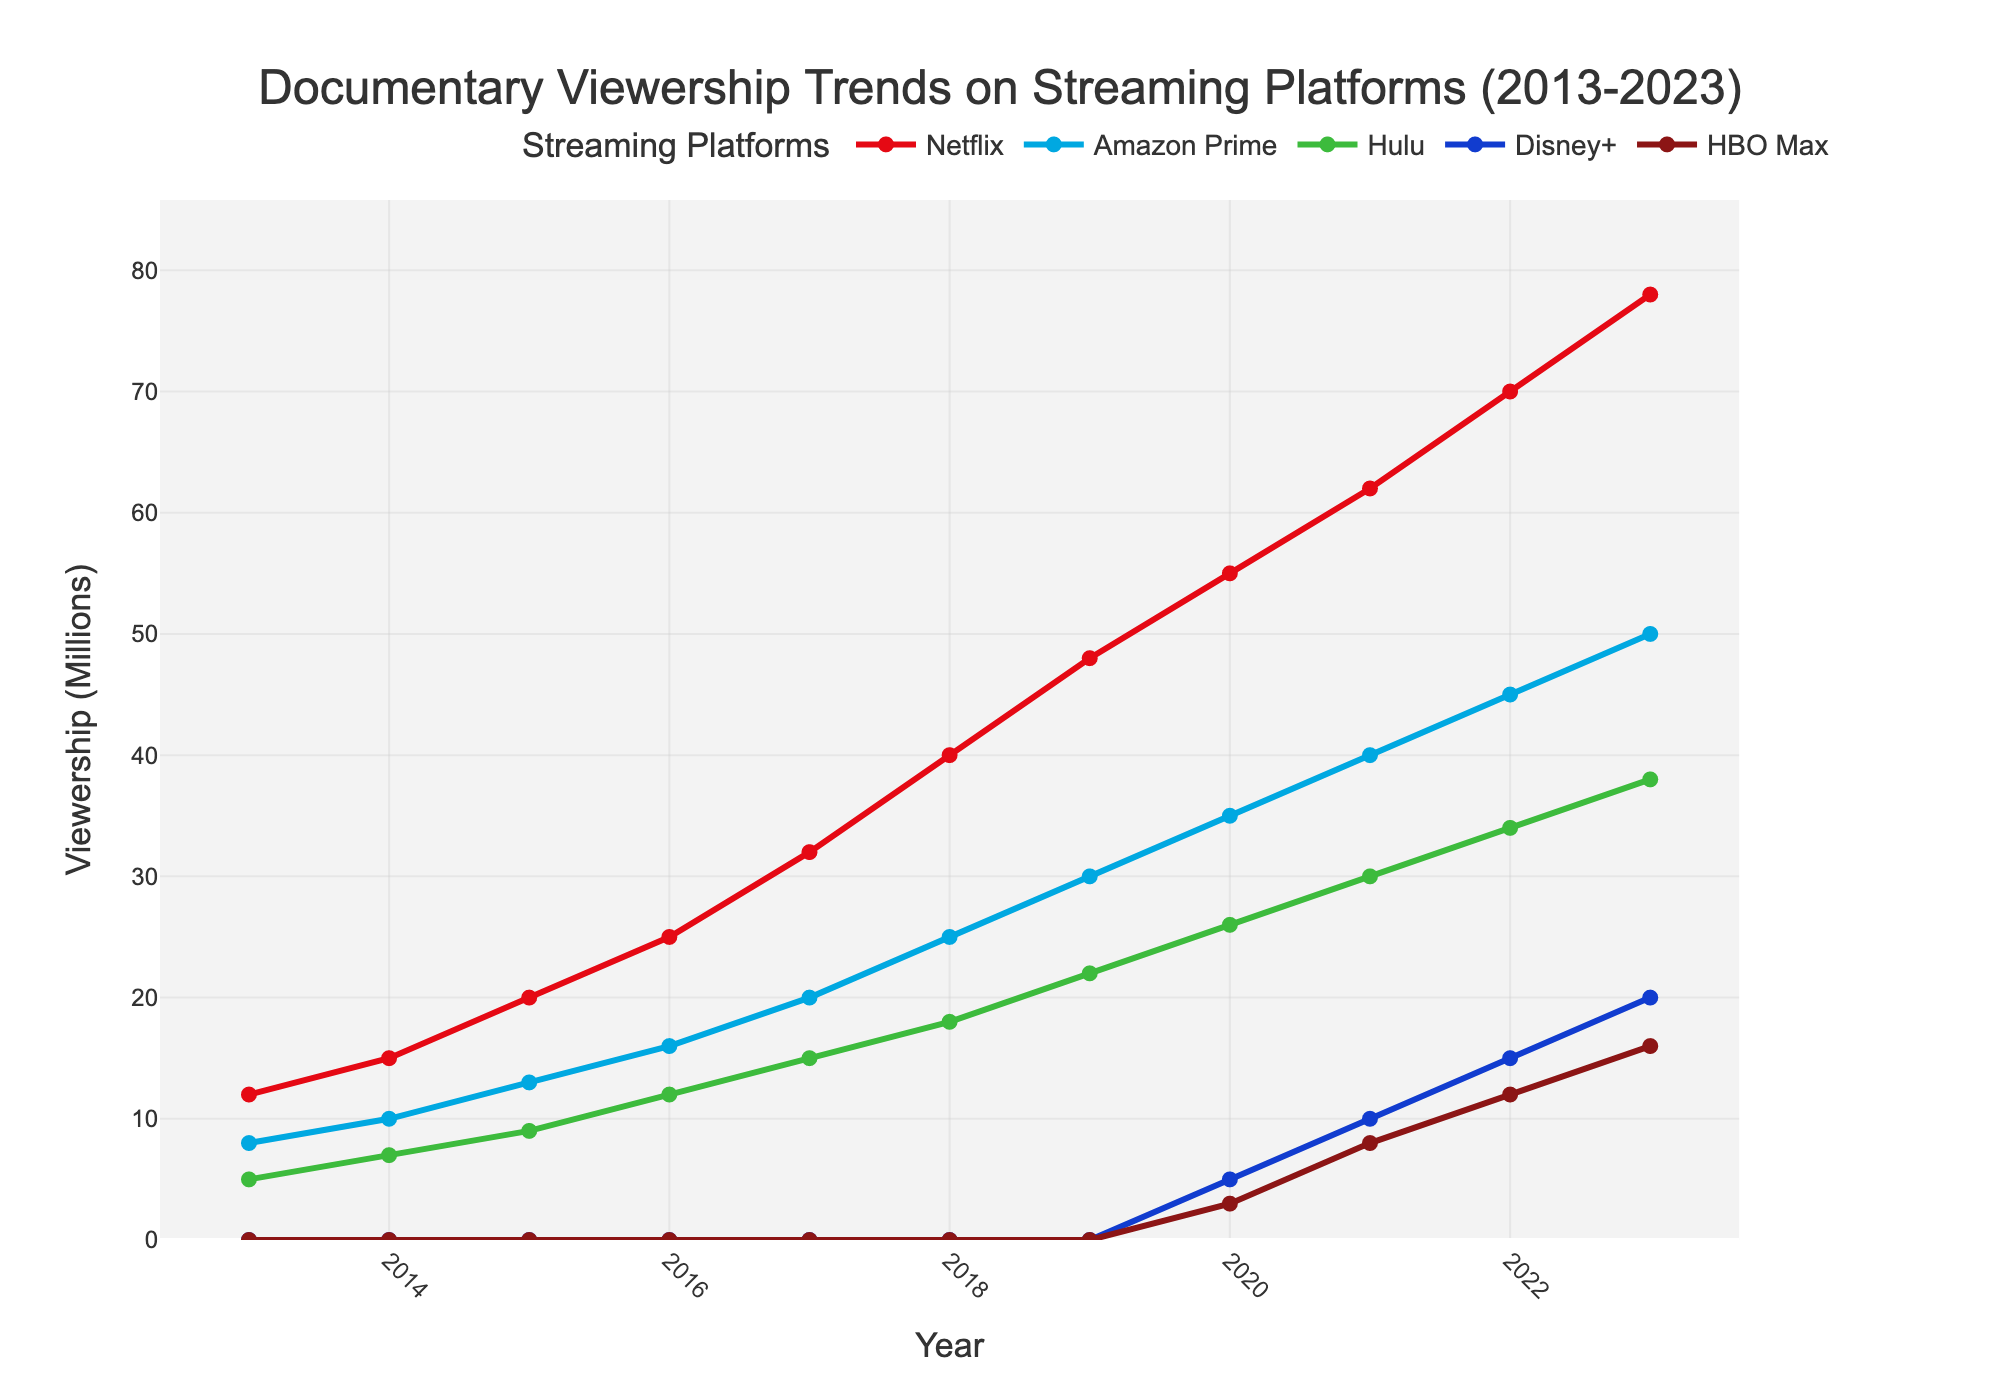What is the general trend in viewership for Netflix from 2013 to 2023? The viewership for Netflix shows a steady increase each year from 12 million in 2013 to 78 million in 2023.
Answer: Steady increase Which year did Disney+ first appear in the viewership data? Disney+ appears in the viewership data for the first time in 2020 with 5 million viewers.
Answer: 2020 In 2023, which streaming platform has the second highest viewership? Looking at the 2023 data, Amazon Prime is the second highest with 50 million viewers.
Answer: Amazon Prime What is the difference in viewership between Hulu and HBO Max in 2021? In 2021, Hulu has 30 million viewers while HBO Max has 8 million viewers. The difference is 30 - 8 = 22 million.
Answer: 22 million Which streaming platform showed the highest increase in viewership from 2019 to 2023? By comparing 2019 and 2023 values: Netflix increased from 48 to 78 (30 million), Amazon Prime from 30 to 50 (20 million), Hulu from 22 to 38 (16 million), Disney+ from 0 to 20 (20 million), and HBO Max from 0 to 16 (16 million). Netflix showed the highest increase with 30 million.
Answer: Netflix How does the viewership growth trend for HBO Max compare to Disney+ since their inception? HBO Max and Disney+ both started in 2020. By 2023, Disney+ goes from 5 to 20 million (15 million increase), while HBO Max goes from 3 to 16 million (13 million increase). Disney+ has a slightly higher viewership growth.
Answer: Disney+ What is the average yearly increase in viewership for Amazon Prime from 2013 to 2023? The increase from 2013 (8 million) to 2023 (50 million) is 42 million over 10 years. This results in an average yearly increase of 42/10 = 4.2 million.
Answer: 4.2 million Compare the viewership of Netflix and Hulu in the year 2017. In 2017, Netflix has 32 million viewers while Hulu has 15 million viewers. Netflix's viewership is 17 million higher than Hulu's.
Answer: Netflix's viewership is 17 million higher Which streaming platform had the most consistent increase in viewership over the years? By examining the line slopes, Netflix shows a consistent and steady increase each year, suggesting the most consistent growth in viewership.
Answer: Netflix 